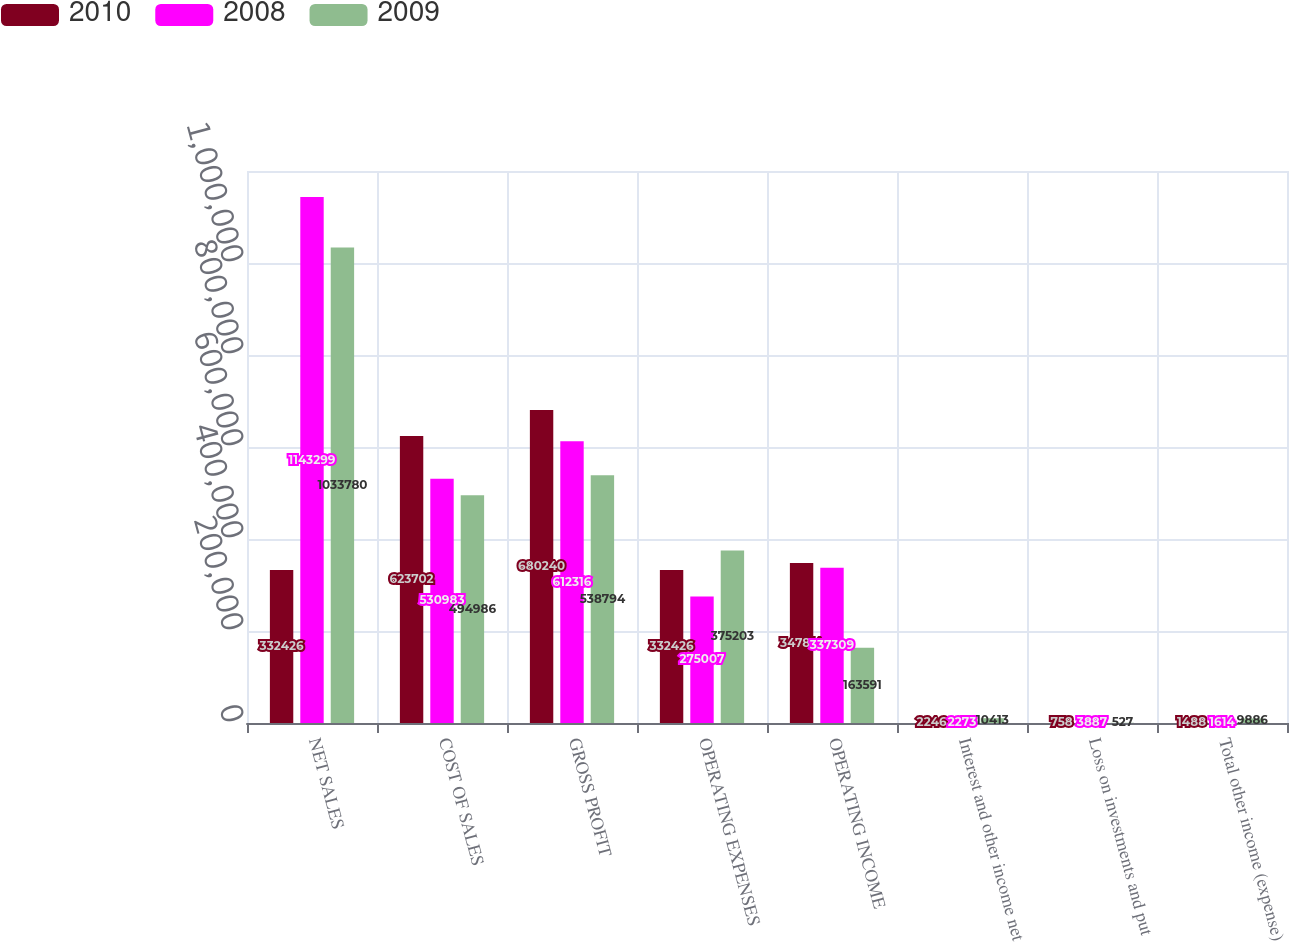Convert chart. <chart><loc_0><loc_0><loc_500><loc_500><stacked_bar_chart><ecel><fcel>NET SALES<fcel>COST OF SALES<fcel>GROSS PROFIT<fcel>OPERATING EXPENSES<fcel>OPERATING INCOME<fcel>Interest and other income net<fcel>Loss on investments and put<fcel>Total other income (expense)<nl><fcel>2010<fcel>332426<fcel>623702<fcel>680240<fcel>332426<fcel>347814<fcel>2246<fcel>758<fcel>1488<nl><fcel>2008<fcel>1.1433e+06<fcel>530983<fcel>612316<fcel>275007<fcel>337309<fcel>2273<fcel>3887<fcel>1614<nl><fcel>2009<fcel>1.03378e+06<fcel>494986<fcel>538794<fcel>375203<fcel>163591<fcel>10413<fcel>527<fcel>9886<nl></chart> 